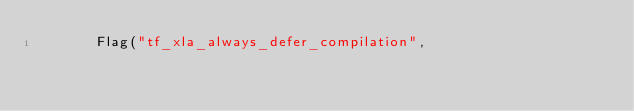Convert code to text. <code><loc_0><loc_0><loc_500><loc_500><_C++_>       Flag("tf_xla_always_defer_compilation",</code> 